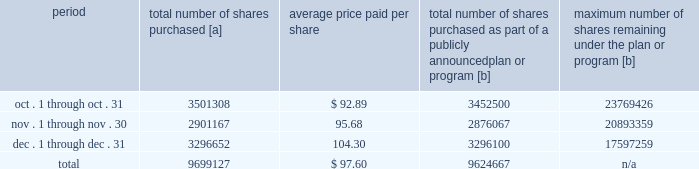Five-year performance comparison 2013 the following graph provides an indicator of cumulative total shareholder returns for the corporation as compared to the peer group index ( described above ) , the dj trans , and the s&p 500 .
The graph assumes that $ 100 was invested in the common stock of union pacific corporation and each index on december 31 , 2011 and that all dividends were reinvested .
The information below is historical in nature and is not necessarily indicative of future performance .
Purchases of equity securities 2013 during 2016 , we repurchased 35686529 shares of our common stock at an average price of $ 88.36 .
The table presents common stock repurchases during each month for the fourth quarter of 2016 : period total number of shares purchased [a] average price paid per share total number of shares purchased as part of a publicly announced plan or program [b] maximum number of shares remaining under the plan or program [b] .
[a] total number of shares purchased during the quarter includes approximately 74460 shares delivered or attested to upc by employees to pay stock option exercise prices , satisfy excess tax withholding obligations for stock option exercises or vesting of retention units , and pay withholding obligations for vesting of retention shares .
[b] effective january 1 , 2014 , our board of directors authorized the repurchase of up to 120 million shares of our common stock by december 31 , 2017 .
These repurchases may be made on the open market or through other transactions .
Our management has sole discretion with respect to determining the timing and amount of these transactions .
On november 17 , 2016 , our board of directors approved the early renewal of the share repurchase program , authorizing the repurchase of up to 120 million shares of our common stock by december 31 , 2020 .
The new authorization was effective january 1 , 2017 , and replaces the previous authorization , which expired on december 31 , 2016. .
During 2016 what was the percent of the number of shares bought in the fourth quarter? 
Computations: (9699127 / 35686529)
Answer: 0.27179. 